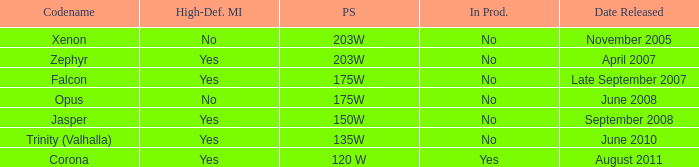Does Trinity (valhalla) have HDMI? Yes. 